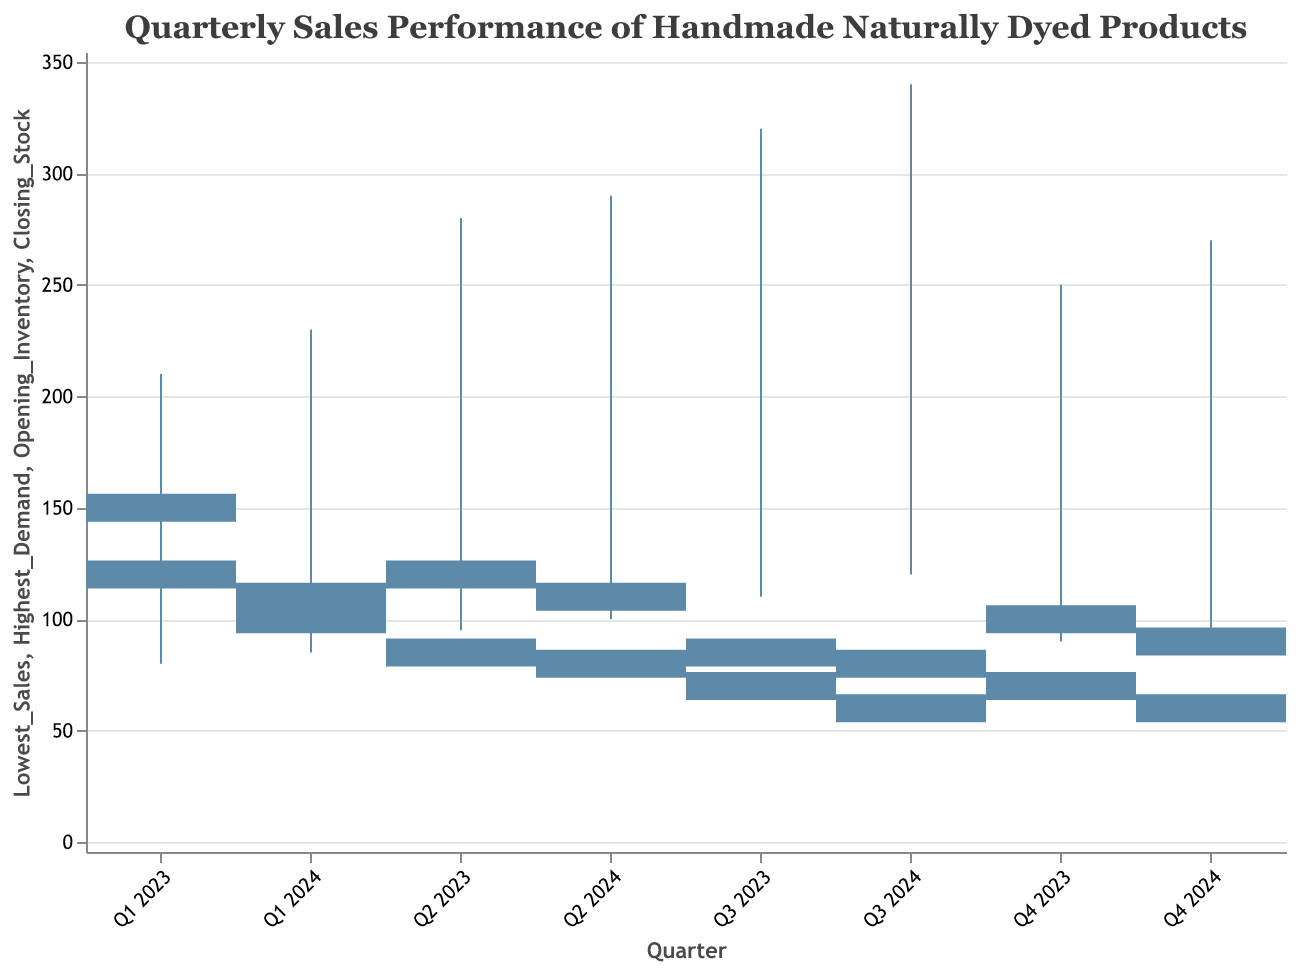What is the title of the chart? The title of the chart can be found at the top of the figure.
Answer: Quarterly Sales Performance of Handmade Naturally Dyed Products Which quarter experienced the highest demand? By examining the highest peak on the vertical rule bars among all quarters, we identify the quarter with the highest demand.
Answer: Q3 2024 What was the lowest level of closing stock observed during this period? We check the lowest horizontal bar for closing stock across all quarters.
Answer: 60 Compare the opening inventory of Q1 2023 and Q1 2024. Which one is higher? By comparing the heights of the opening inventory bars for Q1 2023 and Q1 2024, we determine the higher value.
Answer: Q1 2023 During which quarter in 2023 did the lowest sales occur? By identifying the lowest point on the vertical rule bars for each quarter in 2023, we pinpoint the quarter with the lowest sales.
Answer: Q1 2023 How did the closing stock change from Q2 2023 to Q3 2023? By comparing the heights of the closing stock bars for Q2 2023 and Q3 2023, we calculate the difference.
Answer: Decreased by 15 What is the average highest demand across all quarters in 2024? Add the highest demand values for all quarters in 2024 and divide by the number of quarters. Calculation: (230 + 290 + 340 + 270) / 4 = 1130 / 4 = 282.5
Answer: 282.5 Which quarter had a lower opening inventory: Q3 2024 or Q3 2023? Compare the opening inventory bar heights for Q3 2024 and Q3 2023.
Answer: Q3 2024 What is the total highest demand for all quarters combined? Sum the highest demand values for all quarters. Calculation: 210 + 280 + 320 + 250 + 230 + 290 + 340 + 270 = 2190
Answer: 2190 How many quarters had a closing stock level below 90? Count the number of quarters where the closing stock bar is below 90 on the y-axis.
Answer: 4 